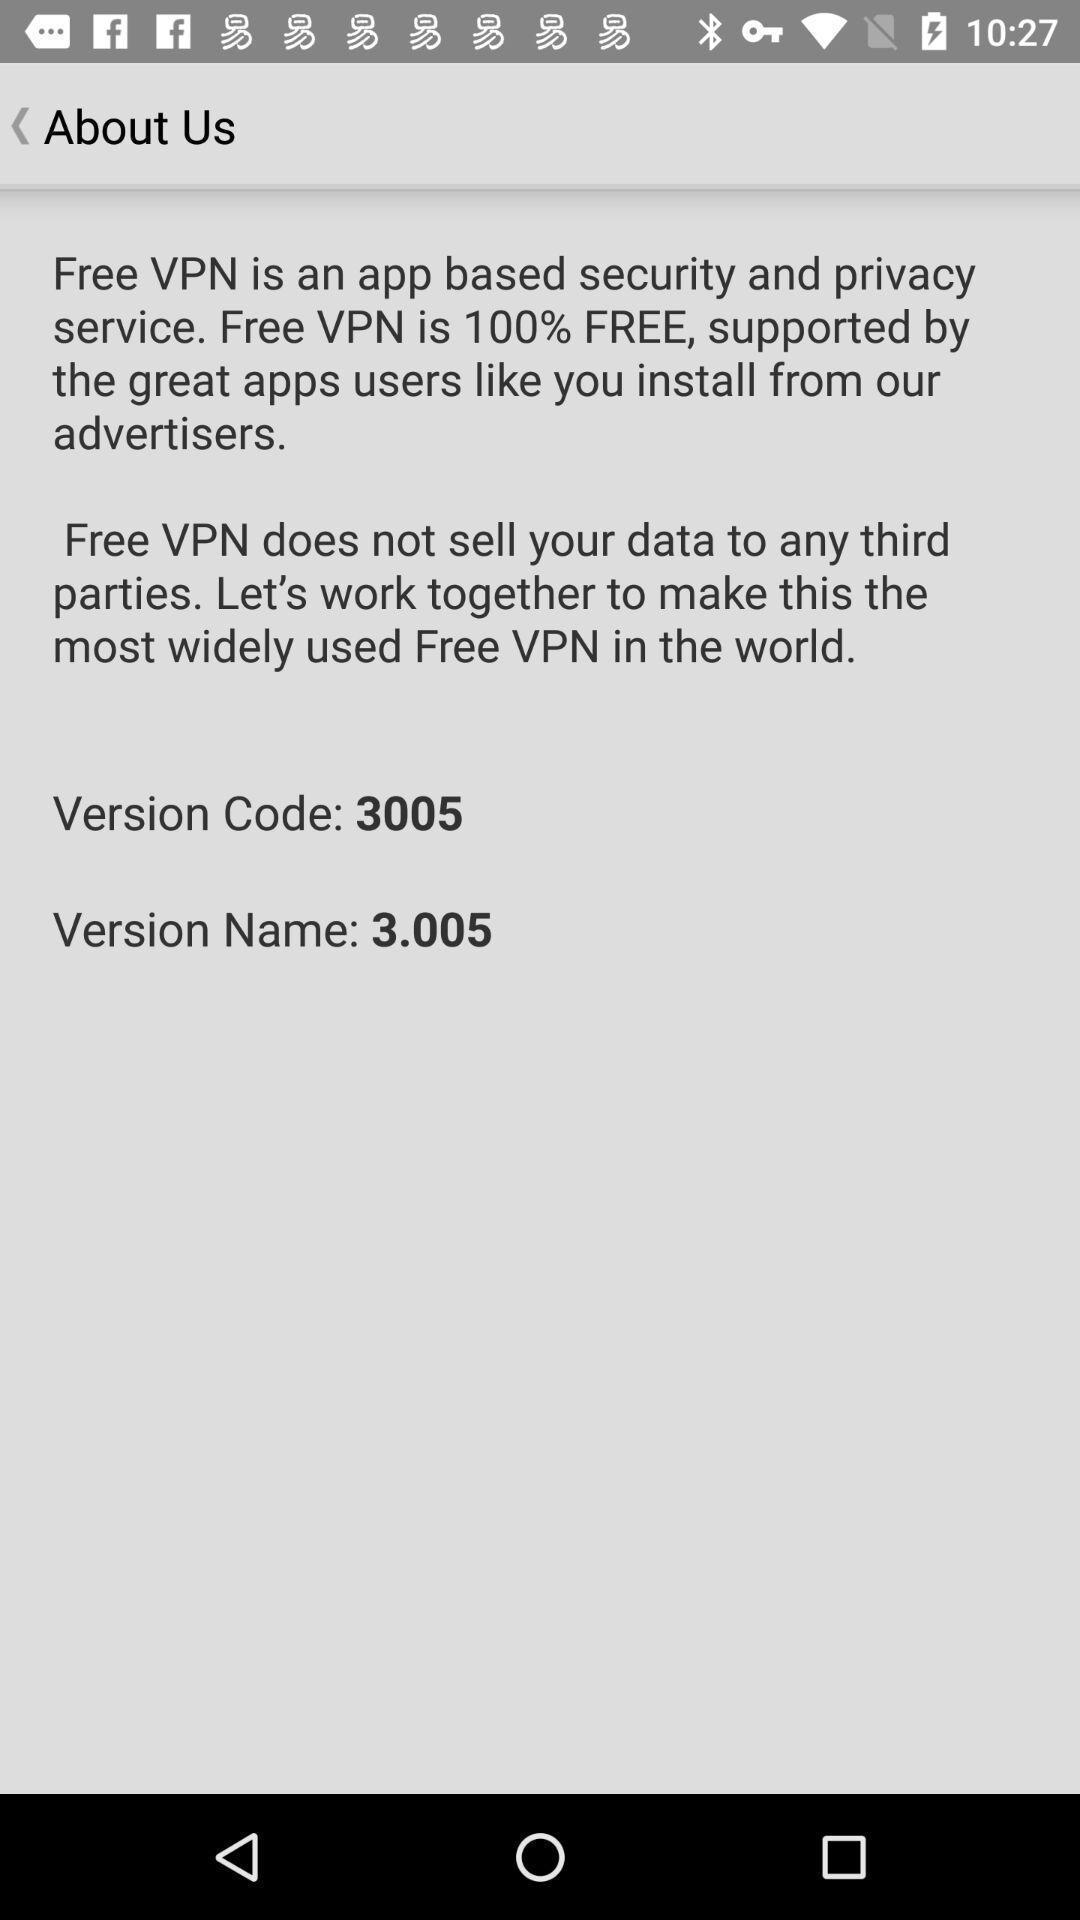Describe the key features of this screenshot. Page showing information about application. 